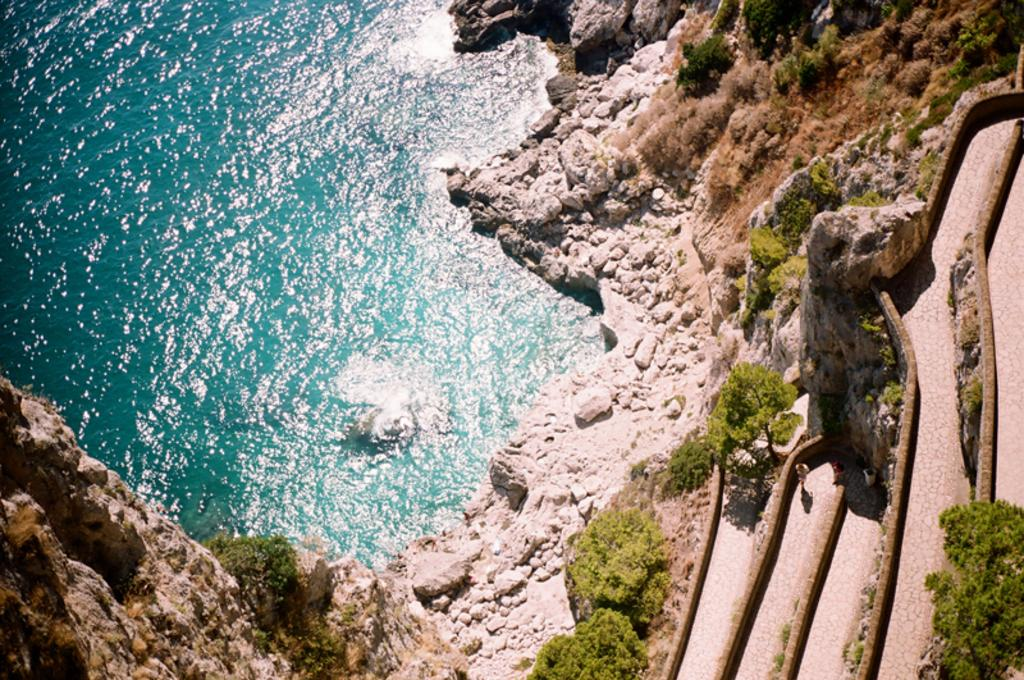What color is the sea in the image? The sea in the image is blue. What can be found on the left side of the image? There are rocks and trees on the left side of the image. What can be found on the right side of the image? There are rocks, trees, and a path to walk and stand on the right side of the image. How many cherries are hanging from the trees in the image? There are no cherries present in the image; the trees are not described as having any fruit. 